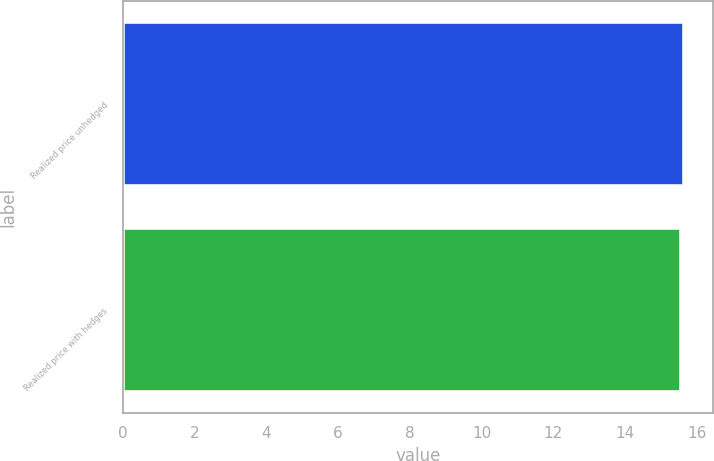Convert chart to OTSL. <chart><loc_0><loc_0><loc_500><loc_500><bar_chart><fcel>Realized price unhedged<fcel>Realized price with hedges<nl><fcel>15.66<fcel>15.56<nl></chart> 